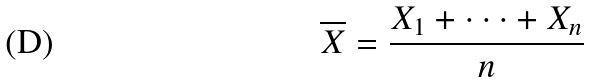Convert formula to latex. <formula><loc_0><loc_0><loc_500><loc_500>\overline { X } = \frac { X _ { 1 } + \cdot \cdot \cdot + X _ { n } } { n }</formula> 